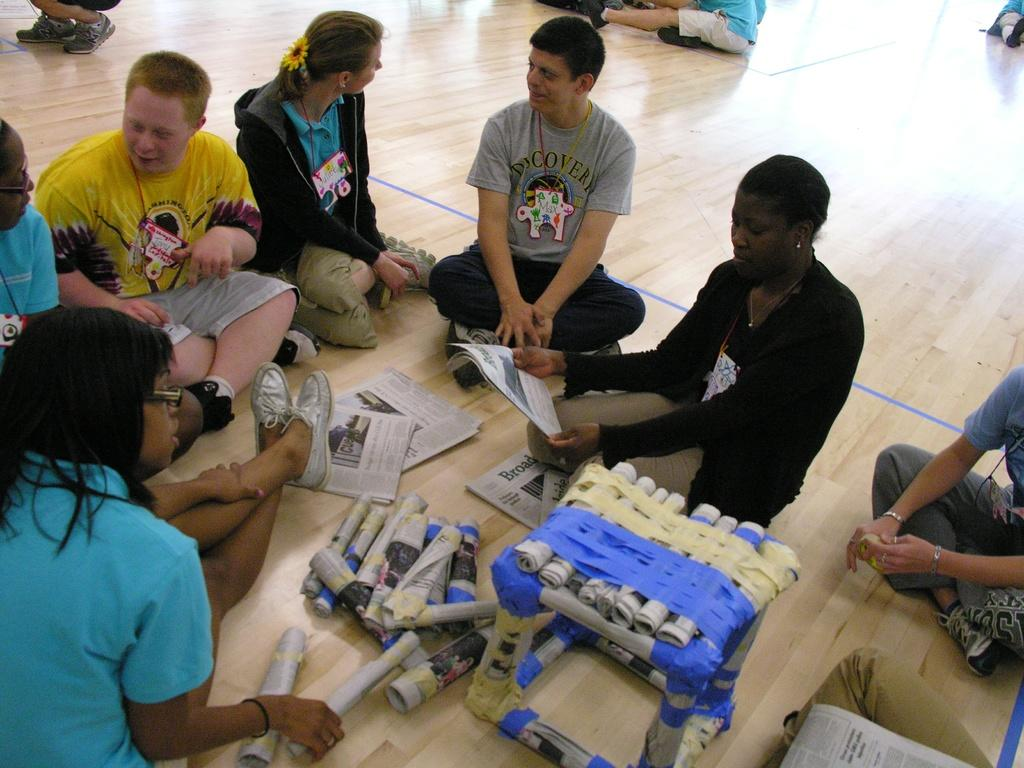What are the people in the image doing? There is a group of people sitting on the floor. What can be seen besides the people in the image? There is a bunch of papers and paper rolls in the image. Can you describe the object made up of rolled paper? There is an object made up of rolled paper in the image. What type of pleasure can be seen in the aftermath of the show in the image? There is no reference to a show or pleasure in the image, as it features a group of people sitting on the floor with papers and paper rolls. 